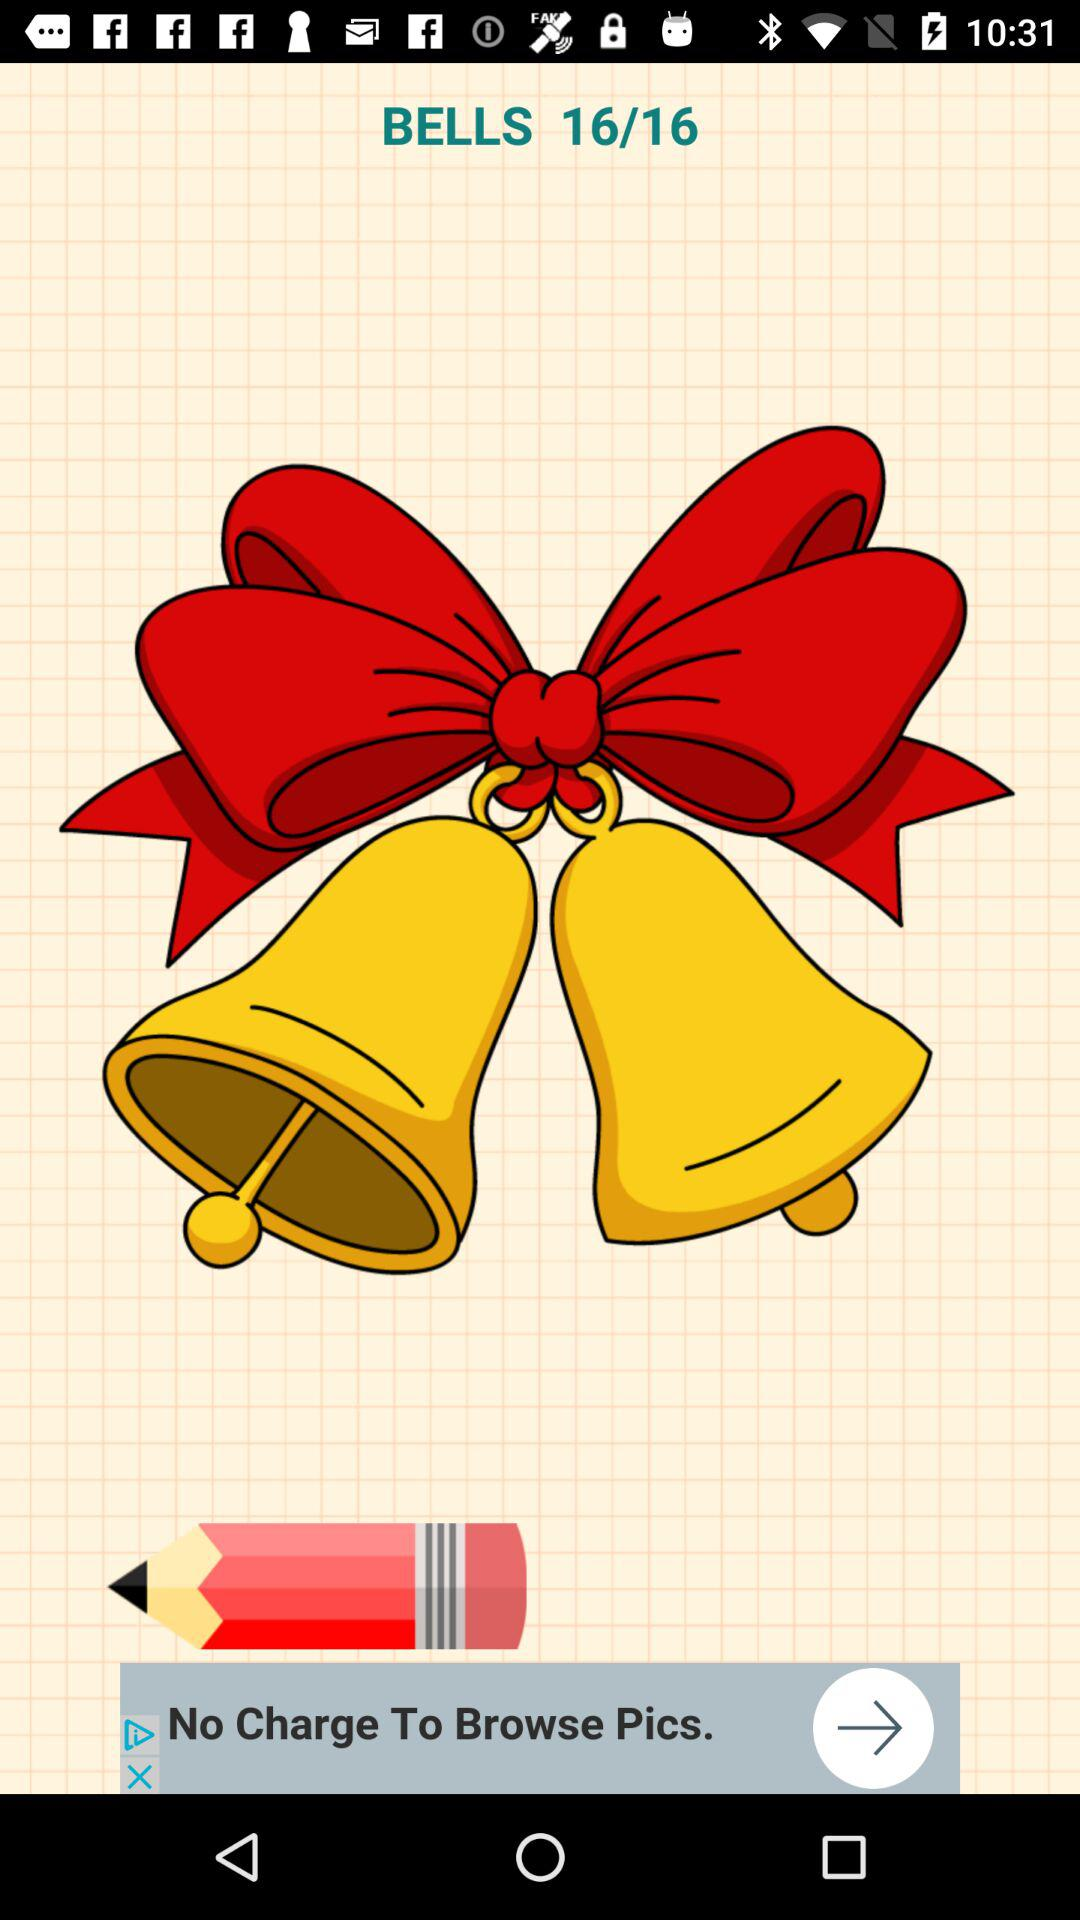How many bell images are there?
When the provided information is insufficient, respond with <no answer>. <no answer> 